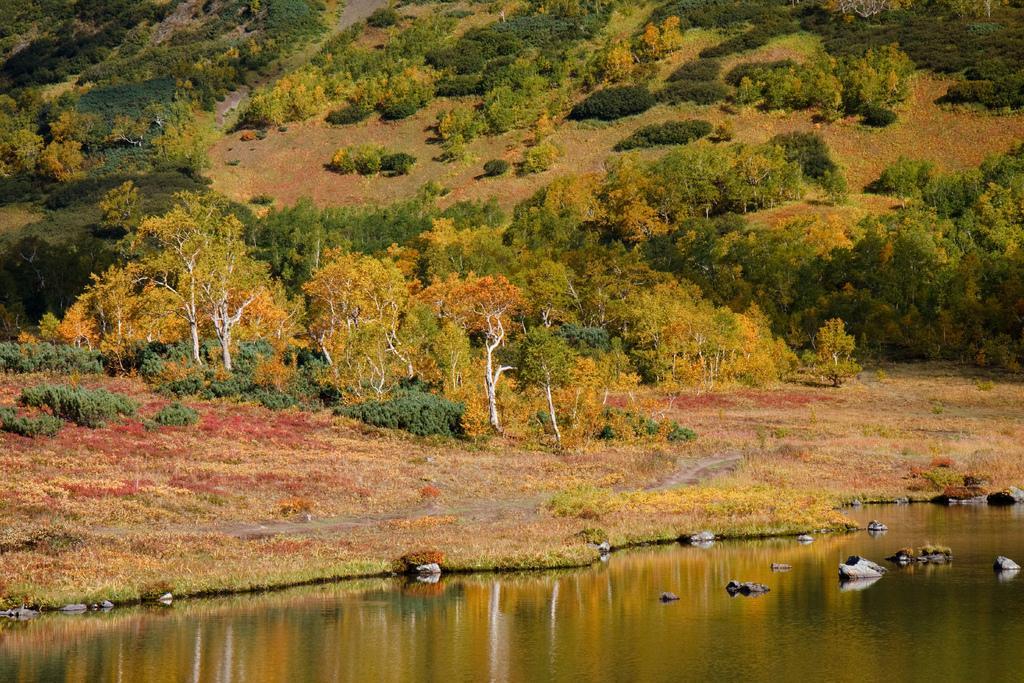Could you give a brief overview of what you see in this image? In this image there is water at the bottom. In the water there are stones. At the top there are so many trees on the hill. Beside the water there is a ground on which there is small grass. 